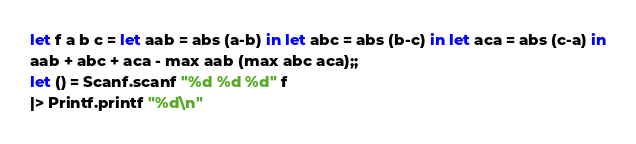<code> <loc_0><loc_0><loc_500><loc_500><_OCaml_>let f a b c = let aab = abs (a-b) in let abc = abs (b-c) in let aca = abs (c-a) in
aab + abc + aca - max aab (max abc aca);;
let () = Scanf.scanf "%d %d %d" f
|> Printf.printf "%d\n"</code> 